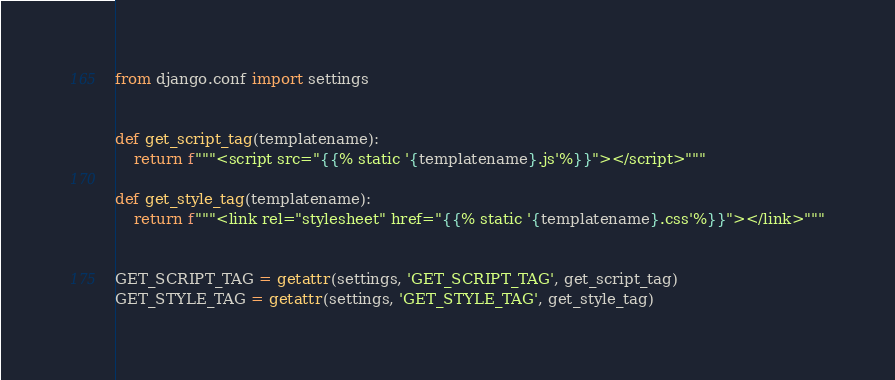Convert code to text. <code><loc_0><loc_0><loc_500><loc_500><_Python_>from django.conf import settings


def get_script_tag(templatename):
    return f"""<script src="{{% static '{templatename}.js'%}}"></script>"""

def get_style_tag(templatename):
    return f"""<link rel="stylesheet" href="{{% static '{templatename}.css'%}}"></link>"""


GET_SCRIPT_TAG = getattr(settings, 'GET_SCRIPT_TAG', get_script_tag)
GET_STYLE_TAG = getattr(settings, 'GET_STYLE_TAG', get_style_tag)
</code> 